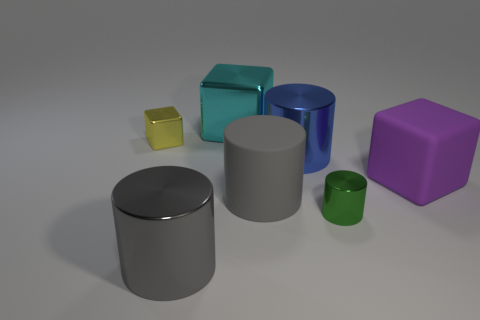Subtract 1 cylinders. How many cylinders are left? 3 Add 1 tiny green rubber spheres. How many objects exist? 8 Subtract all cylinders. How many objects are left? 3 Subtract all gray cubes. Subtract all large cylinders. How many objects are left? 4 Add 6 green metal things. How many green metal things are left? 7 Add 2 big gray matte balls. How many big gray matte balls exist? 2 Subtract 0 red blocks. How many objects are left? 7 